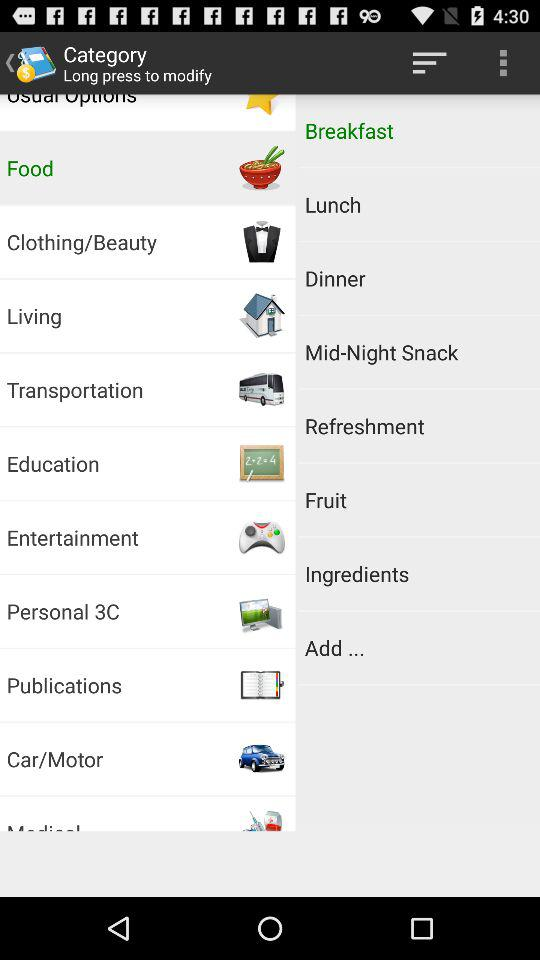Which option has been selected? The selected options are "Food" and "Breakfast". 